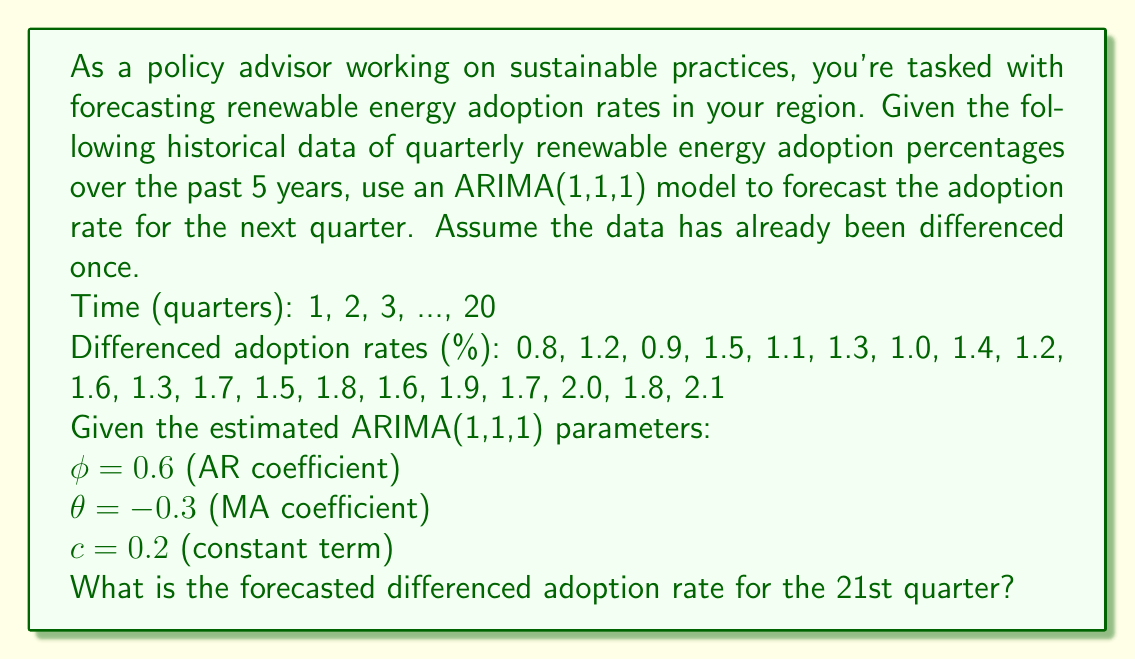Solve this math problem. To forecast the differenced adoption rate for the 21st quarter using an ARIMA(1,1,1) model, we need to use the following equation:

$$y_t = c + \phi y_{t-1} + \varepsilon_t + \theta \varepsilon_{t-1}$$

Where:
$y_t$ is the differenced adoption rate at time t
$c$ is the constant term
$\phi$ is the AR coefficient
$\theta$ is the MA coefficient
$\varepsilon_t$ is the error term at time t

For forecasting, we assume future error terms ($\varepsilon_t$) are zero. We also need the most recent observed value ($y_{20}$) and the most recent estimated error term ($\varepsilon_{20}$).

Steps to calculate the forecast:

1. Identify the most recent observed value: $y_{20} = 2.1$

2. Estimate the most recent error term:
   $\varepsilon_{20} = y_{20} - (c + \phi y_{19} + \theta \varepsilon_{19})$
   We don't have $\varepsilon_{19}$, so we'll assume it's zero for simplicity.
   $\varepsilon_{20} = 2.1 - (0.2 + 0.6 * 1.8 + -0.3 * 0) = 0.82$

3. Apply the ARIMA(1,1,1) equation for the forecast:
   $y_{21} = c + \phi y_{20} + \theta \varepsilon_{20}$
   $y_{21} = 0.2 + 0.6 * 2.1 + (-0.3) * 0.82$
   $y_{21} = 0.2 + 1.26 - 0.246$
   $y_{21} = 1.214$

Therefore, the forecasted differenced adoption rate for the 21st quarter is approximately 1.214%.
Answer: 1.214% 